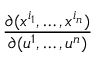<formula> <loc_0><loc_0><loc_500><loc_500>\frac { \partial ( x ^ { i _ { 1 } } , \dots , x ^ { i _ { n } } ) } { \partial ( u ^ { 1 } , \dots , u ^ { n } ) }</formula> 